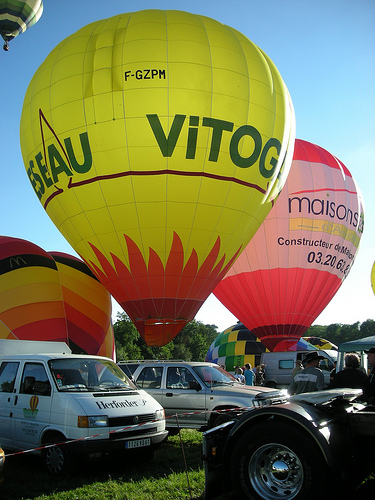<image>
Is the van behind the balloon? Yes. From this viewpoint, the van is positioned behind the balloon, with the balloon partially or fully occluding the van. 